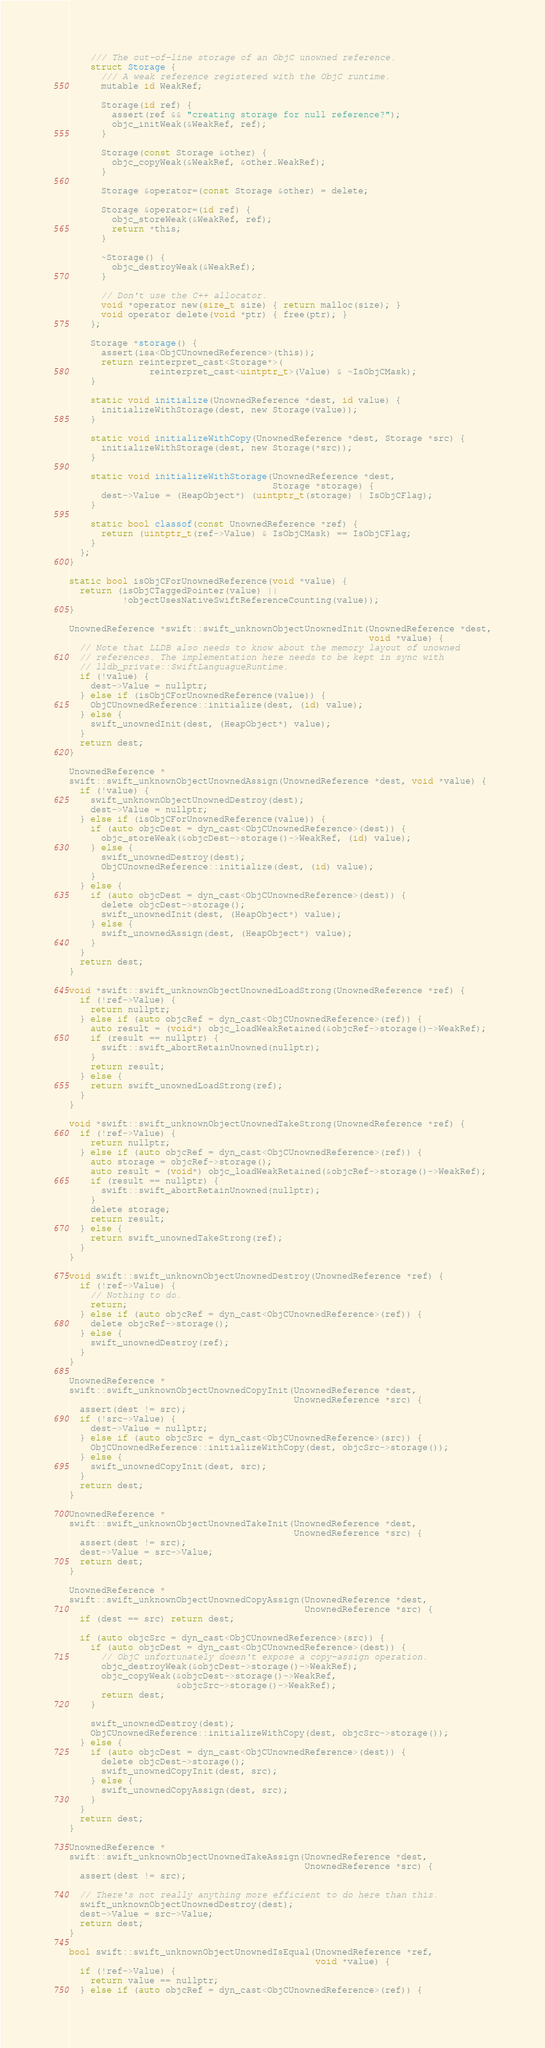Convert code to text. <code><loc_0><loc_0><loc_500><loc_500><_ObjectiveC_>
    /// The out-of-line storage of an ObjC unowned reference.
    struct Storage {
      /// A weak reference registered with the ObjC runtime.
      mutable id WeakRef;

      Storage(id ref) {
        assert(ref && "creating storage for null reference?");
        objc_initWeak(&WeakRef, ref);
      }

      Storage(const Storage &other) {
        objc_copyWeak(&WeakRef, &other.WeakRef);
      }

      Storage &operator=(const Storage &other) = delete;

      Storage &operator=(id ref) {
        objc_storeWeak(&WeakRef, ref);
        return *this;
      }

      ~Storage() {
        objc_destroyWeak(&WeakRef);
      }

      // Don't use the C++ allocator.
      void *operator new(size_t size) { return malloc(size); }
      void operator delete(void *ptr) { free(ptr); }
    };

    Storage *storage() {
      assert(isa<ObjCUnownedReference>(this));
      return reinterpret_cast<Storage*>(
               reinterpret_cast<uintptr_t>(Value) & ~IsObjCMask);
    }

    static void initialize(UnownedReference *dest, id value) {
      initializeWithStorage(dest, new Storage(value));
    }

    static void initializeWithCopy(UnownedReference *dest, Storage *src) {
      initializeWithStorage(dest, new Storage(*src));
    }

    static void initializeWithStorage(UnownedReference *dest,
                                      Storage *storage) {
      dest->Value = (HeapObject*) (uintptr_t(storage) | IsObjCFlag);
    }

    static bool classof(const UnownedReference *ref) {
      return (uintptr_t(ref->Value) & IsObjCMask) == IsObjCFlag;
    }
  };
}

static bool isObjCForUnownedReference(void *value) {
  return (isObjCTaggedPointer(value) ||
          !objectUsesNativeSwiftReferenceCounting(value));
}

UnownedReference *swift::swift_unknownObjectUnownedInit(UnownedReference *dest,
                                                        void *value) {
  // Note that LLDB also needs to know about the memory layout of unowned
  // references. The implementation here needs to be kept in sync with
  // lldb_private::SwiftLanguagueRuntime.
  if (!value) {
    dest->Value = nullptr;
  } else if (isObjCForUnownedReference(value)) {
    ObjCUnownedReference::initialize(dest, (id) value);
  } else {
    swift_unownedInit(dest, (HeapObject*) value);
  }
  return dest;
}

UnownedReference *
swift::swift_unknownObjectUnownedAssign(UnownedReference *dest, void *value) {
  if (!value) {
    swift_unknownObjectUnownedDestroy(dest);
    dest->Value = nullptr;
  } else if (isObjCForUnownedReference(value)) {
    if (auto objcDest = dyn_cast<ObjCUnownedReference>(dest)) {
      objc_storeWeak(&objcDest->storage()->WeakRef, (id) value);
    } else {
      swift_unownedDestroy(dest);
      ObjCUnownedReference::initialize(dest, (id) value);
    }
  } else {
    if (auto objcDest = dyn_cast<ObjCUnownedReference>(dest)) {
      delete objcDest->storage();
      swift_unownedInit(dest, (HeapObject*) value);
    } else {
      swift_unownedAssign(dest, (HeapObject*) value);
    }
  }
  return dest;
}

void *swift::swift_unknownObjectUnownedLoadStrong(UnownedReference *ref) {
  if (!ref->Value) {
    return nullptr;
  } else if (auto objcRef = dyn_cast<ObjCUnownedReference>(ref)) {
    auto result = (void*) objc_loadWeakRetained(&objcRef->storage()->WeakRef);
    if (result == nullptr) {
      swift::swift_abortRetainUnowned(nullptr);
    }
    return result;
  } else {
    return swift_unownedLoadStrong(ref);
  }
}

void *swift::swift_unknownObjectUnownedTakeStrong(UnownedReference *ref) {
  if (!ref->Value) {
    return nullptr;
  } else if (auto objcRef = dyn_cast<ObjCUnownedReference>(ref)) {
    auto storage = objcRef->storage();
    auto result = (void*) objc_loadWeakRetained(&objcRef->storage()->WeakRef);
    if (result == nullptr) {
      swift::swift_abortRetainUnowned(nullptr);
    }
    delete storage;
    return result;
  } else {
    return swift_unownedTakeStrong(ref);
  }
}

void swift::swift_unknownObjectUnownedDestroy(UnownedReference *ref) {
  if (!ref->Value) {
    // Nothing to do.
    return;
  } else if (auto objcRef = dyn_cast<ObjCUnownedReference>(ref)) {
    delete objcRef->storage();
  } else {
    swift_unownedDestroy(ref);
  }
}

UnownedReference *
swift::swift_unknownObjectUnownedCopyInit(UnownedReference *dest,
                                          UnownedReference *src) {
  assert(dest != src);
  if (!src->Value) {
    dest->Value = nullptr;
  } else if (auto objcSrc = dyn_cast<ObjCUnownedReference>(src)) {
    ObjCUnownedReference::initializeWithCopy(dest, objcSrc->storage());
  } else {
    swift_unownedCopyInit(dest, src);
  }
  return dest;
}

UnownedReference *
swift::swift_unknownObjectUnownedTakeInit(UnownedReference *dest,
                                          UnownedReference *src) {
  assert(dest != src);
  dest->Value = src->Value;
  return dest;
}

UnownedReference *
swift::swift_unknownObjectUnownedCopyAssign(UnownedReference *dest,
                                            UnownedReference *src) {
  if (dest == src) return dest;

  if (auto objcSrc = dyn_cast<ObjCUnownedReference>(src)) {
    if (auto objcDest = dyn_cast<ObjCUnownedReference>(dest)) {
      // ObjC unfortunately doesn't expose a copy-assign operation.
      objc_destroyWeak(&objcDest->storage()->WeakRef);
      objc_copyWeak(&objcDest->storage()->WeakRef,
                    &objcSrc->storage()->WeakRef);
      return dest;
    }

    swift_unownedDestroy(dest);
    ObjCUnownedReference::initializeWithCopy(dest, objcSrc->storage());
  } else {
    if (auto objcDest = dyn_cast<ObjCUnownedReference>(dest)) {
      delete objcDest->storage();
      swift_unownedCopyInit(dest, src);
    } else {
      swift_unownedCopyAssign(dest, src);
    }
  }
  return dest;
}

UnownedReference *
swift::swift_unknownObjectUnownedTakeAssign(UnownedReference *dest,
                                            UnownedReference *src) {
  assert(dest != src);

  // There's not really anything more efficient to do here than this.
  swift_unknownObjectUnownedDestroy(dest);
  dest->Value = src->Value;
  return dest;
}

bool swift::swift_unknownObjectUnownedIsEqual(UnownedReference *ref,
                                              void *value) {
  if (!ref->Value) {
    return value == nullptr;
  } else if (auto objcRef = dyn_cast<ObjCUnownedReference>(ref)) {</code> 